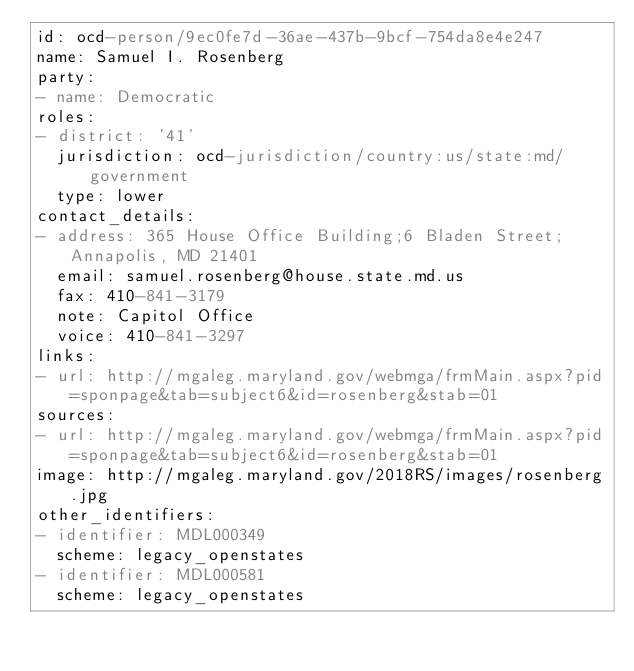<code> <loc_0><loc_0><loc_500><loc_500><_YAML_>id: ocd-person/9ec0fe7d-36ae-437b-9bcf-754da8e4e247
name: Samuel I. Rosenberg
party:
- name: Democratic
roles:
- district: '41'
  jurisdiction: ocd-jurisdiction/country:us/state:md/government
  type: lower
contact_details:
- address: 365 House Office Building;6 Bladen Street;Annapolis, MD 21401
  email: samuel.rosenberg@house.state.md.us
  fax: 410-841-3179
  note: Capitol Office
  voice: 410-841-3297
links:
- url: http://mgaleg.maryland.gov/webmga/frmMain.aspx?pid=sponpage&tab=subject6&id=rosenberg&stab=01
sources:
- url: http://mgaleg.maryland.gov/webmga/frmMain.aspx?pid=sponpage&tab=subject6&id=rosenberg&stab=01
image: http://mgaleg.maryland.gov/2018RS/images/rosenberg.jpg
other_identifiers:
- identifier: MDL000349
  scheme: legacy_openstates
- identifier: MDL000581
  scheme: legacy_openstates
</code> 